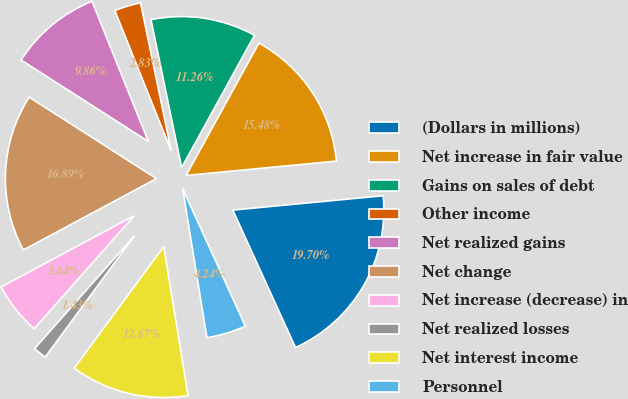<chart> <loc_0><loc_0><loc_500><loc_500><pie_chart><fcel>(Dollars in millions)<fcel>Net increase in fair value<fcel>Gains on sales of debt<fcel>Other income<fcel>Net realized gains<fcel>Net change<fcel>Net increase (decrease) in<fcel>Net realized losses<fcel>Net interest income<fcel>Personnel<nl><fcel>19.7%<fcel>15.48%<fcel>11.26%<fcel>2.83%<fcel>9.86%<fcel>16.89%<fcel>5.64%<fcel>1.43%<fcel>12.67%<fcel>4.24%<nl></chart> 